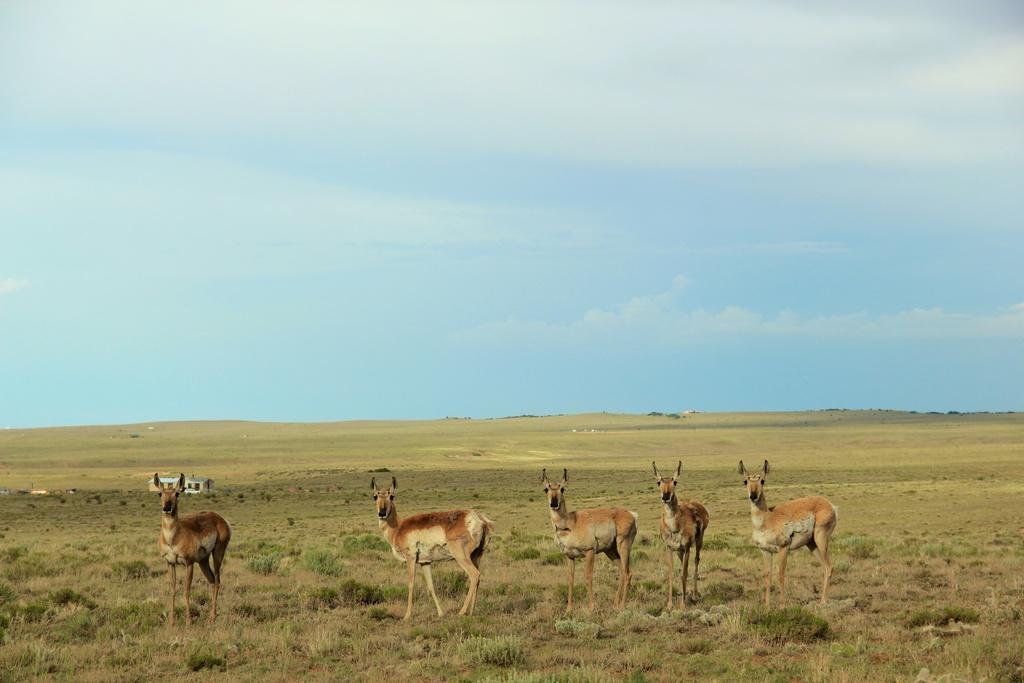In one or two sentences, can you explain what this image depicts? In this image we can see a herd standing on the grass, shed and sky with clouds. 